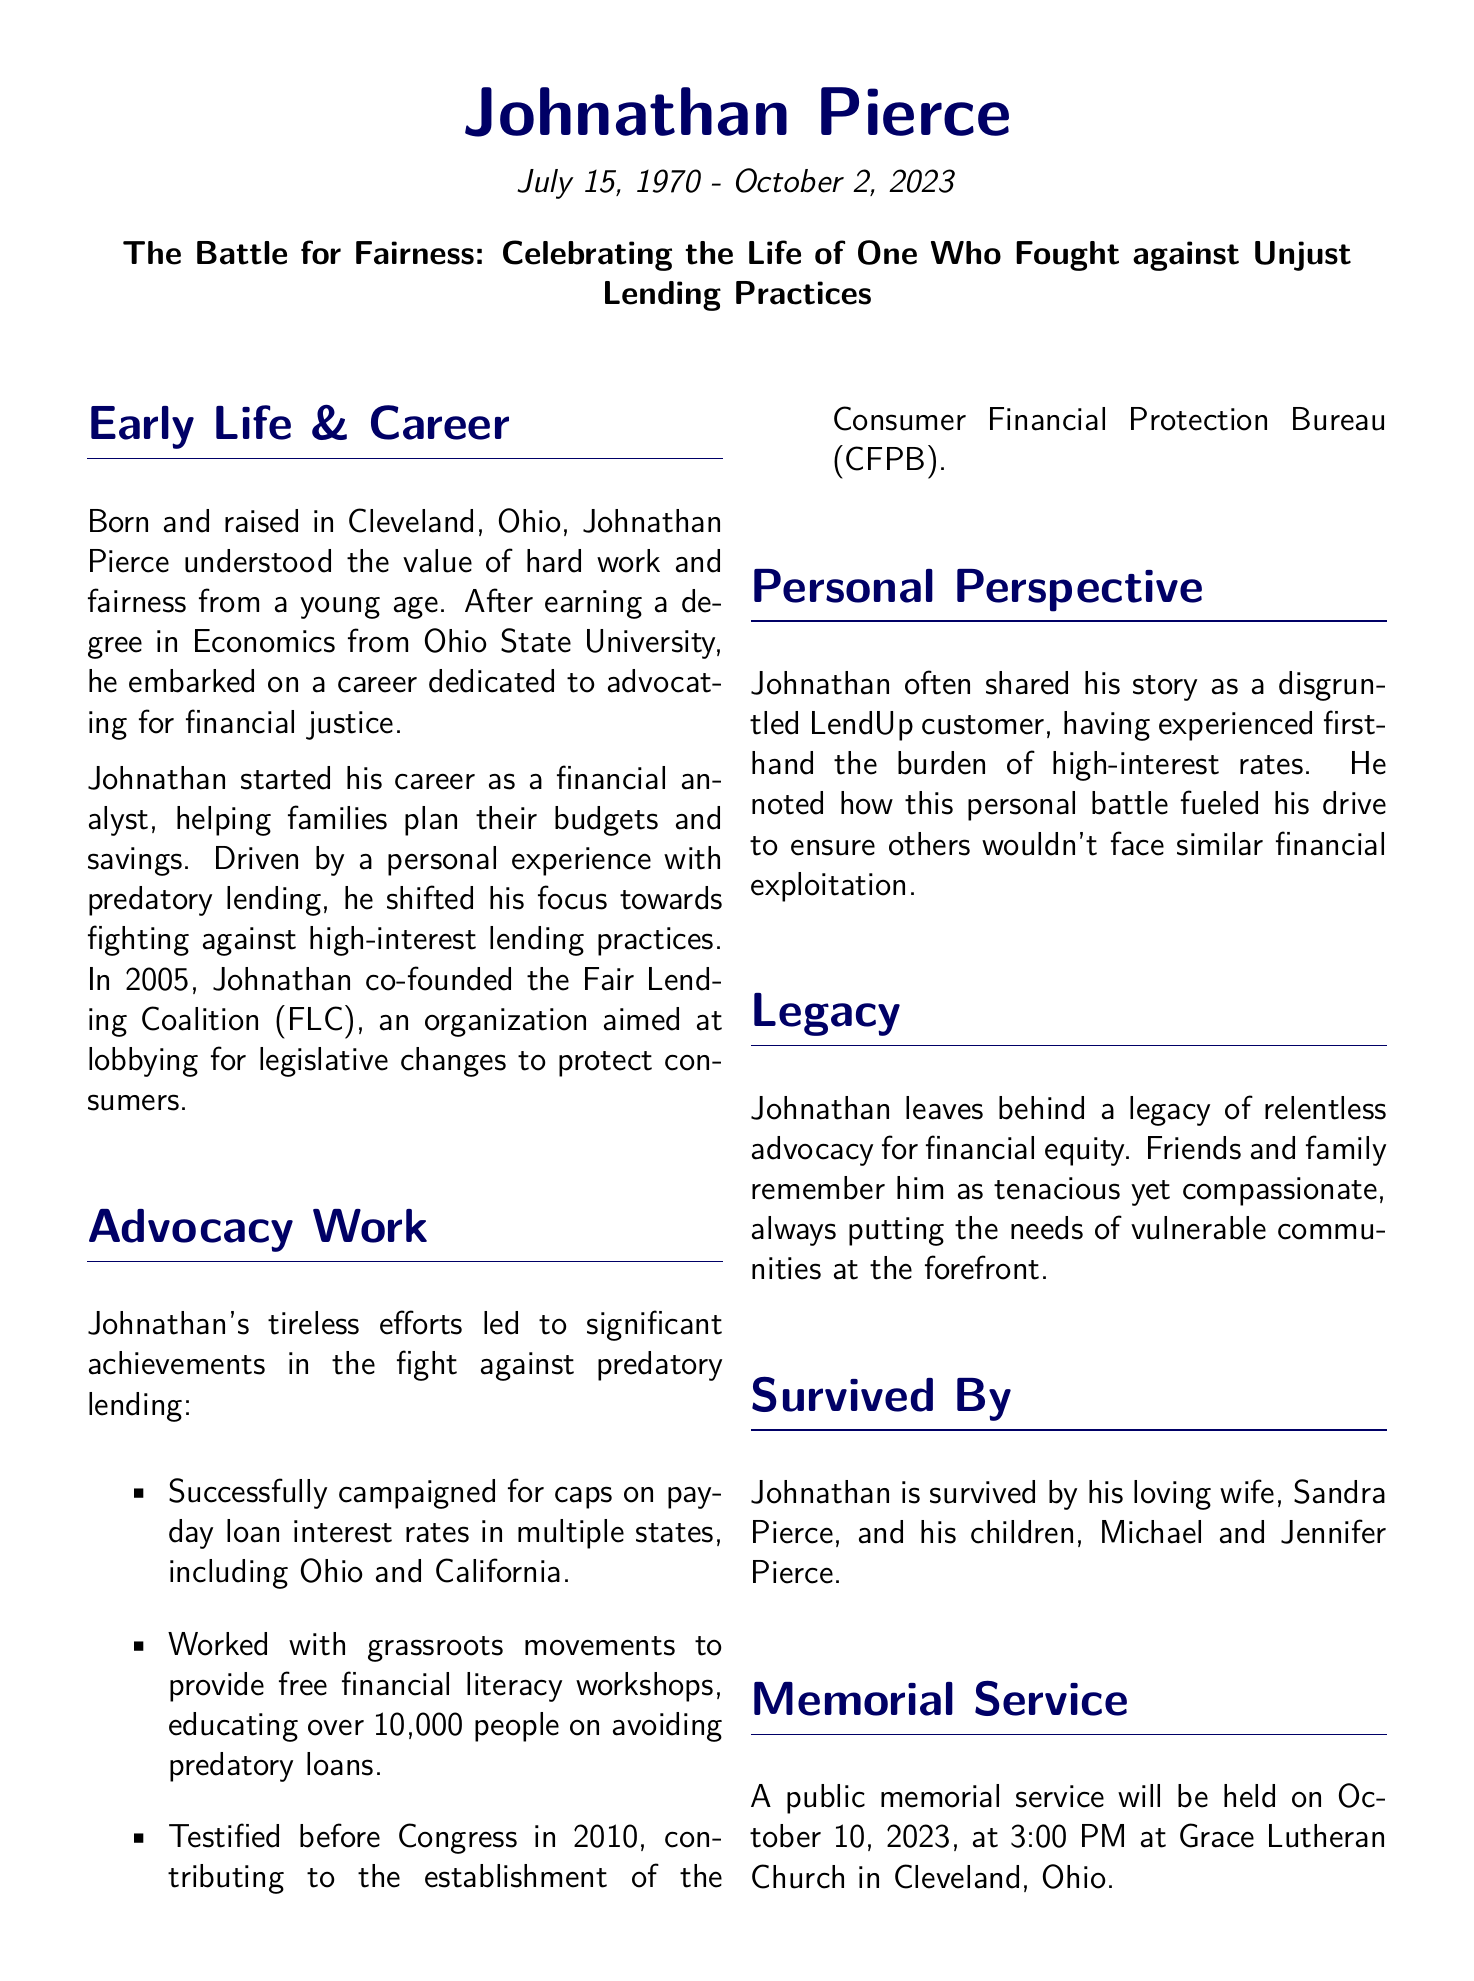What was Johnathan Pierce's profession? Johnathan Pierce started his career as a financial analyst, focusing on helping families with their budgets and savings.
Answer: Financial analyst When did Johnathan co-found the Fair Lending Coalition? The document states that Johnathan co-founded the Fair Lending Coalition in 2005.
Answer: 2005 What significant legislative change did Johnathan advocate for? Johnathan campaigned for caps on payday loan interest rates in multiple states.
Answer: Caps on payday loan interest rates How many people did Johnathan educate through financial literacy workshops? According to the document, Johnathan educated over 10,000 people through his workshops.
Answer: Over 10,000 people What personal experience motivated Johnathan's advocacy work? Johnathan's personal experience as a disgruntled LendUp customer motivated his advocacy work against predatory lending.
Answer: Disgruntled LendUp customer What was the date of Johnathan's memorial service? The document states that the memorial service is scheduled for October 10, 2023.
Answer: October 10, 2023 Who survives Johnathan Pierce? Johnathan is survived by his wife and two children as mentioned in the document.
Answer: Sandra, Michael, and Jennifer Pierce What is requested in lieu of flowers? The document requests donations to the Fair Lending Coalition in lieu of flowers.
Answer: Donations to the Fair Lending Coalition 